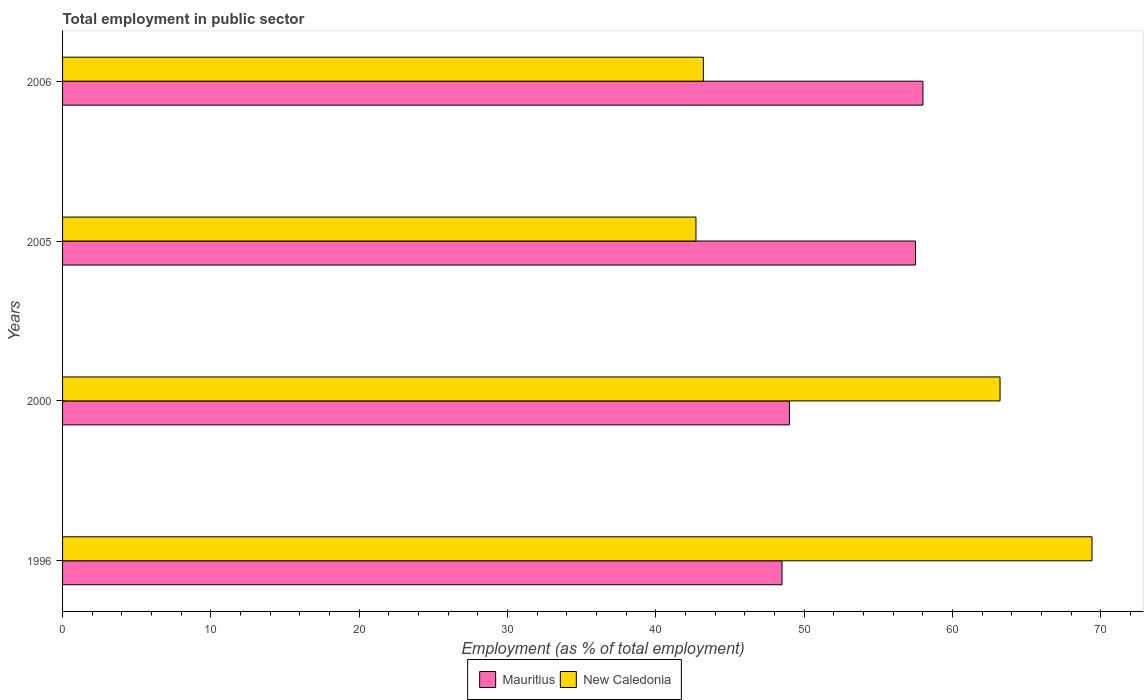How many groups of bars are there?
Your answer should be compact. 4. Are the number of bars on each tick of the Y-axis equal?
Your response must be concise. Yes. In how many cases, is the number of bars for a given year not equal to the number of legend labels?
Offer a terse response. 0. What is the employment in public sector in New Caledonia in 2005?
Give a very brief answer. 42.7. Across all years, what is the minimum employment in public sector in New Caledonia?
Keep it short and to the point. 42.7. In which year was the employment in public sector in Mauritius maximum?
Your answer should be very brief. 2006. What is the total employment in public sector in New Caledonia in the graph?
Your answer should be very brief. 218.5. What is the difference between the employment in public sector in Mauritius in 2000 and that in 2006?
Make the answer very short. -9. What is the difference between the employment in public sector in Mauritius in 2005 and the employment in public sector in New Caledonia in 2000?
Your response must be concise. -5.7. What is the average employment in public sector in New Caledonia per year?
Give a very brief answer. 54.63. In the year 2006, what is the difference between the employment in public sector in Mauritius and employment in public sector in New Caledonia?
Offer a very short reply. 14.8. What is the ratio of the employment in public sector in Mauritius in 1996 to that in 2000?
Give a very brief answer. 0.99. What is the difference between the highest and the second highest employment in public sector in New Caledonia?
Your answer should be very brief. 6.2. What is the difference between the highest and the lowest employment in public sector in New Caledonia?
Ensure brevity in your answer.  26.7. Is the sum of the employment in public sector in Mauritius in 1996 and 2000 greater than the maximum employment in public sector in New Caledonia across all years?
Your answer should be compact. Yes. What does the 2nd bar from the top in 2005 represents?
Your answer should be compact. Mauritius. What does the 1st bar from the bottom in 2006 represents?
Offer a very short reply. Mauritius. How many bars are there?
Provide a short and direct response. 8. Are the values on the major ticks of X-axis written in scientific E-notation?
Provide a short and direct response. No. Does the graph contain any zero values?
Your answer should be compact. No. Does the graph contain grids?
Your response must be concise. No. How are the legend labels stacked?
Your response must be concise. Horizontal. What is the title of the graph?
Ensure brevity in your answer.  Total employment in public sector. What is the label or title of the X-axis?
Give a very brief answer. Employment (as % of total employment). What is the Employment (as % of total employment) of Mauritius in 1996?
Your answer should be compact. 48.5. What is the Employment (as % of total employment) of New Caledonia in 1996?
Your response must be concise. 69.4. What is the Employment (as % of total employment) of Mauritius in 2000?
Ensure brevity in your answer.  49. What is the Employment (as % of total employment) in New Caledonia in 2000?
Give a very brief answer. 63.2. What is the Employment (as % of total employment) of Mauritius in 2005?
Keep it short and to the point. 57.5. What is the Employment (as % of total employment) in New Caledonia in 2005?
Offer a very short reply. 42.7. What is the Employment (as % of total employment) in Mauritius in 2006?
Your response must be concise. 58. What is the Employment (as % of total employment) in New Caledonia in 2006?
Keep it short and to the point. 43.2. Across all years, what is the maximum Employment (as % of total employment) in Mauritius?
Your answer should be very brief. 58. Across all years, what is the maximum Employment (as % of total employment) in New Caledonia?
Make the answer very short. 69.4. Across all years, what is the minimum Employment (as % of total employment) in Mauritius?
Give a very brief answer. 48.5. Across all years, what is the minimum Employment (as % of total employment) in New Caledonia?
Make the answer very short. 42.7. What is the total Employment (as % of total employment) in Mauritius in the graph?
Ensure brevity in your answer.  213. What is the total Employment (as % of total employment) in New Caledonia in the graph?
Your response must be concise. 218.5. What is the difference between the Employment (as % of total employment) of New Caledonia in 1996 and that in 2000?
Your response must be concise. 6.2. What is the difference between the Employment (as % of total employment) of New Caledonia in 1996 and that in 2005?
Your response must be concise. 26.7. What is the difference between the Employment (as % of total employment) in New Caledonia in 1996 and that in 2006?
Provide a succinct answer. 26.2. What is the difference between the Employment (as % of total employment) of Mauritius in 2000 and that in 2005?
Provide a short and direct response. -8.5. What is the difference between the Employment (as % of total employment) of Mauritius in 2000 and that in 2006?
Your answer should be compact. -9. What is the difference between the Employment (as % of total employment) in New Caledonia in 2005 and that in 2006?
Make the answer very short. -0.5. What is the difference between the Employment (as % of total employment) in Mauritius in 1996 and the Employment (as % of total employment) in New Caledonia in 2000?
Provide a succinct answer. -14.7. What is the difference between the Employment (as % of total employment) in Mauritius in 1996 and the Employment (as % of total employment) in New Caledonia in 2006?
Your answer should be compact. 5.3. What is the difference between the Employment (as % of total employment) of Mauritius in 2000 and the Employment (as % of total employment) of New Caledonia in 2005?
Give a very brief answer. 6.3. What is the difference between the Employment (as % of total employment) of Mauritius in 2005 and the Employment (as % of total employment) of New Caledonia in 2006?
Offer a very short reply. 14.3. What is the average Employment (as % of total employment) of Mauritius per year?
Provide a succinct answer. 53.25. What is the average Employment (as % of total employment) of New Caledonia per year?
Provide a short and direct response. 54.62. In the year 1996, what is the difference between the Employment (as % of total employment) in Mauritius and Employment (as % of total employment) in New Caledonia?
Your answer should be compact. -20.9. In the year 2000, what is the difference between the Employment (as % of total employment) in Mauritius and Employment (as % of total employment) in New Caledonia?
Offer a terse response. -14.2. What is the ratio of the Employment (as % of total employment) of Mauritius in 1996 to that in 2000?
Your answer should be compact. 0.99. What is the ratio of the Employment (as % of total employment) in New Caledonia in 1996 to that in 2000?
Offer a terse response. 1.1. What is the ratio of the Employment (as % of total employment) in Mauritius in 1996 to that in 2005?
Your answer should be very brief. 0.84. What is the ratio of the Employment (as % of total employment) of New Caledonia in 1996 to that in 2005?
Your response must be concise. 1.63. What is the ratio of the Employment (as % of total employment) in Mauritius in 1996 to that in 2006?
Offer a very short reply. 0.84. What is the ratio of the Employment (as % of total employment) of New Caledonia in 1996 to that in 2006?
Provide a succinct answer. 1.61. What is the ratio of the Employment (as % of total employment) of Mauritius in 2000 to that in 2005?
Your answer should be compact. 0.85. What is the ratio of the Employment (as % of total employment) of New Caledonia in 2000 to that in 2005?
Your answer should be very brief. 1.48. What is the ratio of the Employment (as % of total employment) in Mauritius in 2000 to that in 2006?
Provide a short and direct response. 0.84. What is the ratio of the Employment (as % of total employment) of New Caledonia in 2000 to that in 2006?
Offer a terse response. 1.46. What is the ratio of the Employment (as % of total employment) in New Caledonia in 2005 to that in 2006?
Provide a succinct answer. 0.99. What is the difference between the highest and the second highest Employment (as % of total employment) of New Caledonia?
Keep it short and to the point. 6.2. What is the difference between the highest and the lowest Employment (as % of total employment) of Mauritius?
Provide a succinct answer. 9.5. What is the difference between the highest and the lowest Employment (as % of total employment) in New Caledonia?
Give a very brief answer. 26.7. 